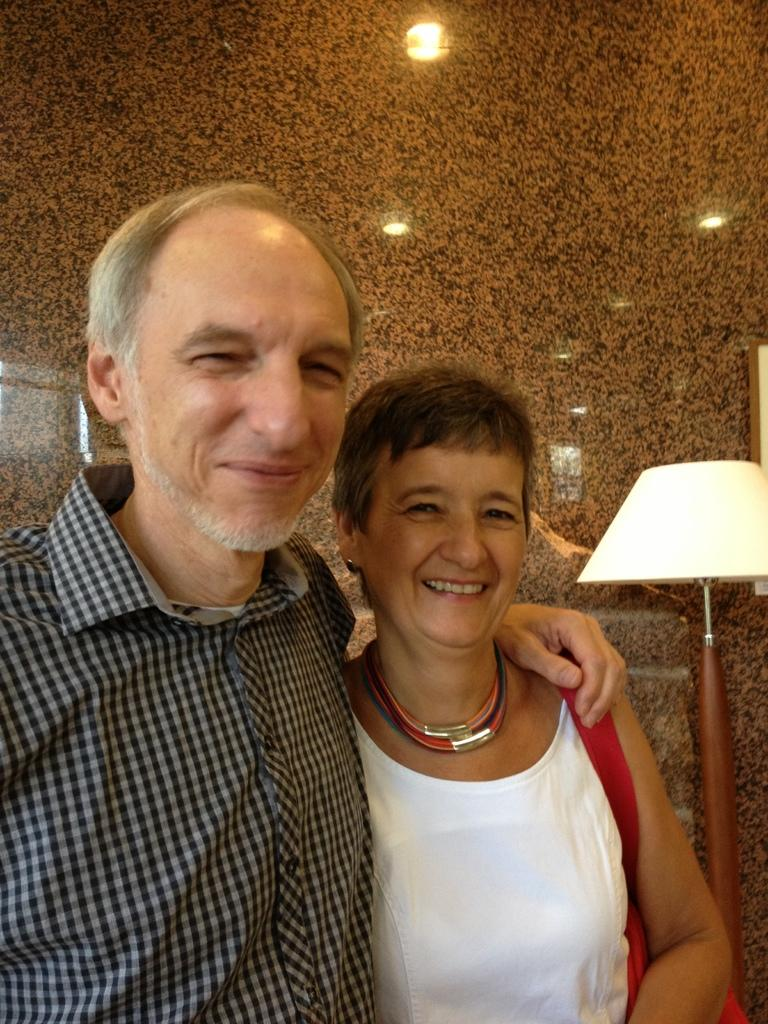How many people are present in the image? There are two people in the image, a man and a woman. What is the woman wearing in the image? The woman is wearing a bag in the image. What object can be seen providing illumination in the image? There is a lamp in the image. What is attached to the wall in the image? Lights are visible on the wall in the image. What type of berry is being used as a decoration on the man's face in the image? There is no berry present on the man's face in the image. Are there any fairies visible in the image? There are no fairies present in the image. 